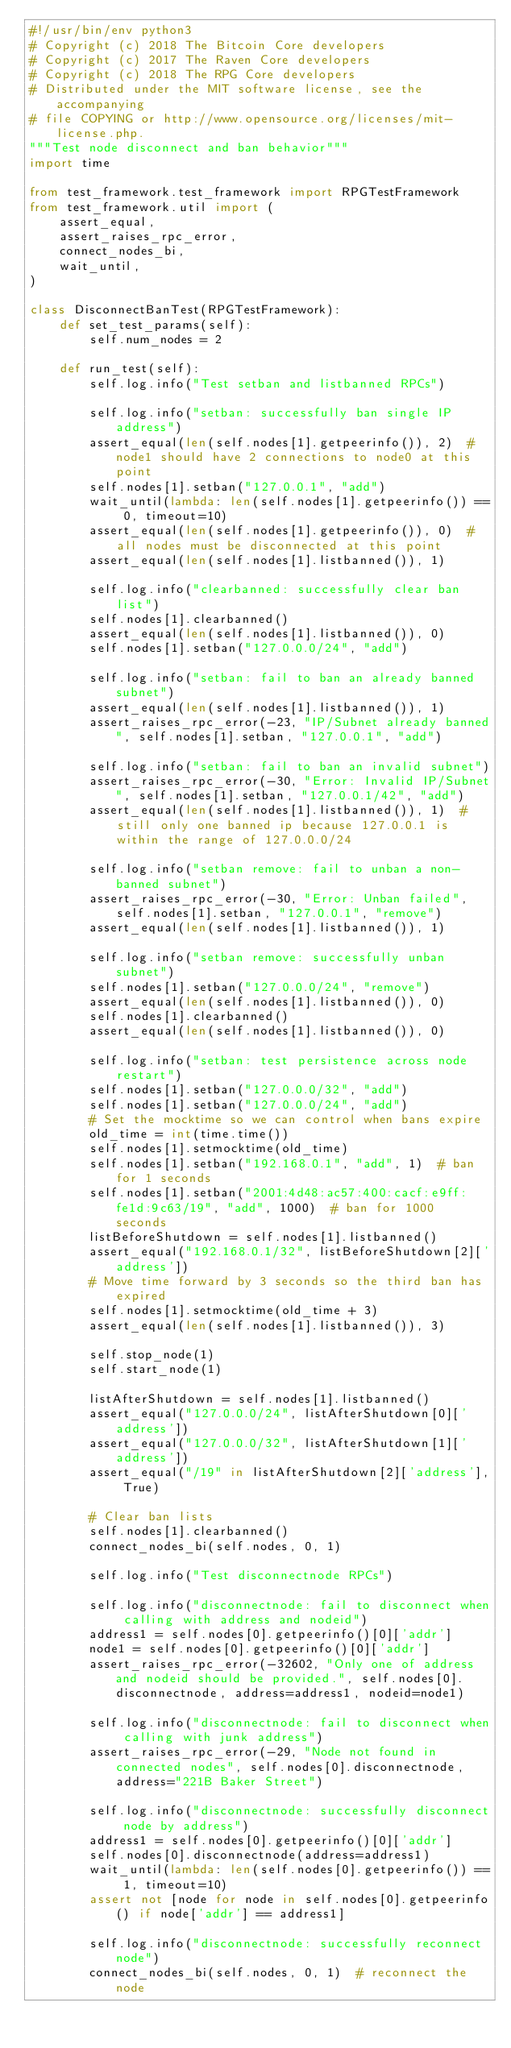Convert code to text. <code><loc_0><loc_0><loc_500><loc_500><_Python_>#!/usr/bin/env python3
# Copyright (c) 2018 The Bitcoin Core developers
# Copyright (c) 2017 The Raven Core developers
# Copyright (c) 2018 The RPG Core developers
# Distributed under the MIT software license, see the accompanying
# file COPYING or http://www.opensource.org/licenses/mit-license.php.
"""Test node disconnect and ban behavior"""
import time

from test_framework.test_framework import RPGTestFramework
from test_framework.util import (
    assert_equal,
    assert_raises_rpc_error,
    connect_nodes_bi,
    wait_until,
)

class DisconnectBanTest(RPGTestFramework):
    def set_test_params(self):
        self.num_nodes = 2

    def run_test(self):
        self.log.info("Test setban and listbanned RPCs")

        self.log.info("setban: successfully ban single IP address")
        assert_equal(len(self.nodes[1].getpeerinfo()), 2)  # node1 should have 2 connections to node0 at this point
        self.nodes[1].setban("127.0.0.1", "add")
        wait_until(lambda: len(self.nodes[1].getpeerinfo()) == 0, timeout=10)
        assert_equal(len(self.nodes[1].getpeerinfo()), 0)  # all nodes must be disconnected at this point
        assert_equal(len(self.nodes[1].listbanned()), 1)

        self.log.info("clearbanned: successfully clear ban list")
        self.nodes[1].clearbanned()
        assert_equal(len(self.nodes[1].listbanned()), 0)
        self.nodes[1].setban("127.0.0.0/24", "add")

        self.log.info("setban: fail to ban an already banned subnet")
        assert_equal(len(self.nodes[1].listbanned()), 1)
        assert_raises_rpc_error(-23, "IP/Subnet already banned", self.nodes[1].setban, "127.0.0.1", "add")

        self.log.info("setban: fail to ban an invalid subnet")
        assert_raises_rpc_error(-30, "Error: Invalid IP/Subnet", self.nodes[1].setban, "127.0.0.1/42", "add")
        assert_equal(len(self.nodes[1].listbanned()), 1)  # still only one banned ip because 127.0.0.1 is within the range of 127.0.0.0/24

        self.log.info("setban remove: fail to unban a non-banned subnet")
        assert_raises_rpc_error(-30, "Error: Unban failed", self.nodes[1].setban, "127.0.0.1", "remove")
        assert_equal(len(self.nodes[1].listbanned()), 1)

        self.log.info("setban remove: successfully unban subnet")
        self.nodes[1].setban("127.0.0.0/24", "remove")
        assert_equal(len(self.nodes[1].listbanned()), 0)
        self.nodes[1].clearbanned()
        assert_equal(len(self.nodes[1].listbanned()), 0)

        self.log.info("setban: test persistence across node restart")
        self.nodes[1].setban("127.0.0.0/32", "add")
        self.nodes[1].setban("127.0.0.0/24", "add")
        # Set the mocktime so we can control when bans expire
        old_time = int(time.time())
        self.nodes[1].setmocktime(old_time)
        self.nodes[1].setban("192.168.0.1", "add", 1)  # ban for 1 seconds
        self.nodes[1].setban("2001:4d48:ac57:400:cacf:e9ff:fe1d:9c63/19", "add", 1000)  # ban for 1000 seconds
        listBeforeShutdown = self.nodes[1].listbanned()
        assert_equal("192.168.0.1/32", listBeforeShutdown[2]['address'])
        # Move time forward by 3 seconds so the third ban has expired
        self.nodes[1].setmocktime(old_time + 3)
        assert_equal(len(self.nodes[1].listbanned()), 3)

        self.stop_node(1)
        self.start_node(1)

        listAfterShutdown = self.nodes[1].listbanned()
        assert_equal("127.0.0.0/24", listAfterShutdown[0]['address'])
        assert_equal("127.0.0.0/32", listAfterShutdown[1]['address'])
        assert_equal("/19" in listAfterShutdown[2]['address'], True)

        # Clear ban lists
        self.nodes[1].clearbanned()
        connect_nodes_bi(self.nodes, 0, 1)

        self.log.info("Test disconnectnode RPCs")

        self.log.info("disconnectnode: fail to disconnect when calling with address and nodeid")
        address1 = self.nodes[0].getpeerinfo()[0]['addr']
        node1 = self.nodes[0].getpeerinfo()[0]['addr']
        assert_raises_rpc_error(-32602, "Only one of address and nodeid should be provided.", self.nodes[0].disconnectnode, address=address1, nodeid=node1)

        self.log.info("disconnectnode: fail to disconnect when calling with junk address")
        assert_raises_rpc_error(-29, "Node not found in connected nodes", self.nodes[0].disconnectnode, address="221B Baker Street")

        self.log.info("disconnectnode: successfully disconnect node by address")
        address1 = self.nodes[0].getpeerinfo()[0]['addr']
        self.nodes[0].disconnectnode(address=address1)
        wait_until(lambda: len(self.nodes[0].getpeerinfo()) == 1, timeout=10)
        assert not [node for node in self.nodes[0].getpeerinfo() if node['addr'] == address1]

        self.log.info("disconnectnode: successfully reconnect node")
        connect_nodes_bi(self.nodes, 0, 1)  # reconnect the node</code> 